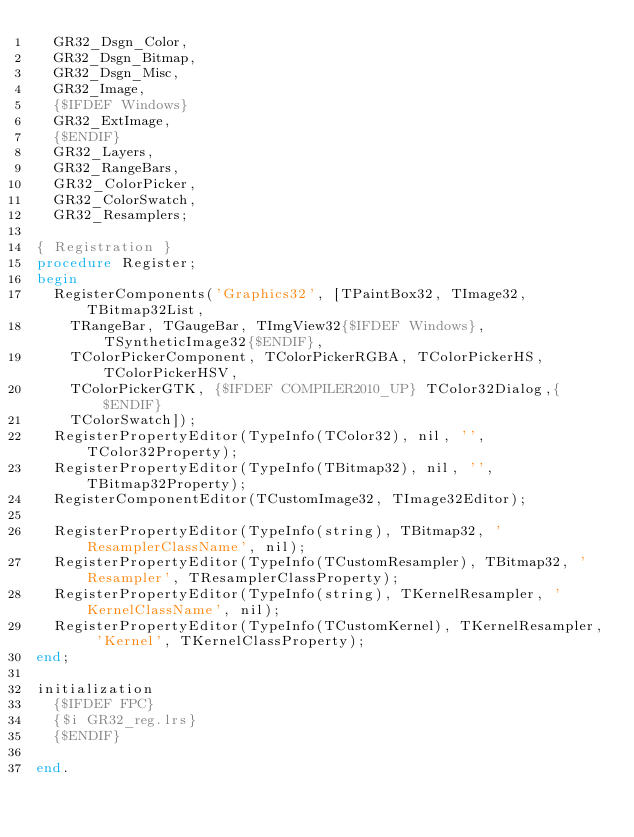<code> <loc_0><loc_0><loc_500><loc_500><_Pascal_>  GR32_Dsgn_Color,
  GR32_Dsgn_Bitmap,
  GR32_Dsgn_Misc,
  GR32_Image,
  {$IFDEF Windows}
  GR32_ExtImage,
  {$ENDIF}
  GR32_Layers,
  GR32_RangeBars,
  GR32_ColorPicker,
  GR32_ColorSwatch,
  GR32_Resamplers;

{ Registration }
procedure Register;
begin
  RegisterComponents('Graphics32', [TPaintBox32, TImage32, TBitmap32List,
    TRangeBar, TGaugeBar, TImgView32{$IFDEF Windows}, TSyntheticImage32{$ENDIF},
    TColorPickerComponent, TColorPickerRGBA, TColorPickerHS, TColorPickerHSV,
    TColorPickerGTK, {$IFDEF COMPILER2010_UP} TColor32Dialog,{$ENDIF}
    TColorSwatch]);
  RegisterPropertyEditor(TypeInfo(TColor32), nil, '', TColor32Property);
  RegisterPropertyEditor(TypeInfo(TBitmap32), nil, '', TBitmap32Property);
  RegisterComponentEditor(TCustomImage32, TImage32Editor);

  RegisterPropertyEditor(TypeInfo(string), TBitmap32, 'ResamplerClassName', nil);
  RegisterPropertyEditor(TypeInfo(TCustomResampler), TBitmap32, 'Resampler', TResamplerClassProperty);
  RegisterPropertyEditor(TypeInfo(string), TKernelResampler, 'KernelClassName', nil);
  RegisterPropertyEditor(TypeInfo(TCustomKernel), TKernelResampler, 'Kernel', TKernelClassProperty);
end;

initialization
  {$IFDEF FPC}
  {$i GR32_reg.lrs}
  {$ENDIF}

end.

</code> 